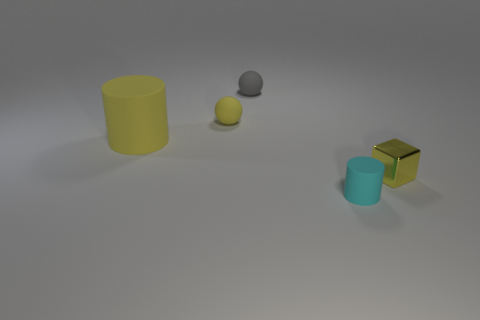What shape is the yellow object on the right side of the small cyan object?
Your response must be concise. Cube. Are there more tiny gray matte objects than purple matte cylinders?
Keep it short and to the point. Yes. Do the cylinder that is in front of the yellow shiny cube and the metallic object have the same color?
Provide a short and direct response. No. What number of objects are either objects that are in front of the yellow matte cylinder or cylinders that are on the left side of the yellow sphere?
Offer a terse response. 3. How many cylinders are behind the cube and to the right of the gray sphere?
Your answer should be compact. 0. Does the yellow sphere have the same material as the small cyan thing?
Your response must be concise. Yes. There is a tiny matte object in front of the small yellow object in front of the rubber cylinder to the left of the cyan matte cylinder; what is its shape?
Ensure brevity in your answer.  Cylinder. What is the small thing that is both in front of the gray ball and behind the large yellow object made of?
Keep it short and to the point. Rubber. There is a cylinder right of the cylinder behind the tiny matte thing that is in front of the large yellow object; what color is it?
Offer a very short reply. Cyan. How many yellow things are spheres or cylinders?
Your answer should be compact. 2. 